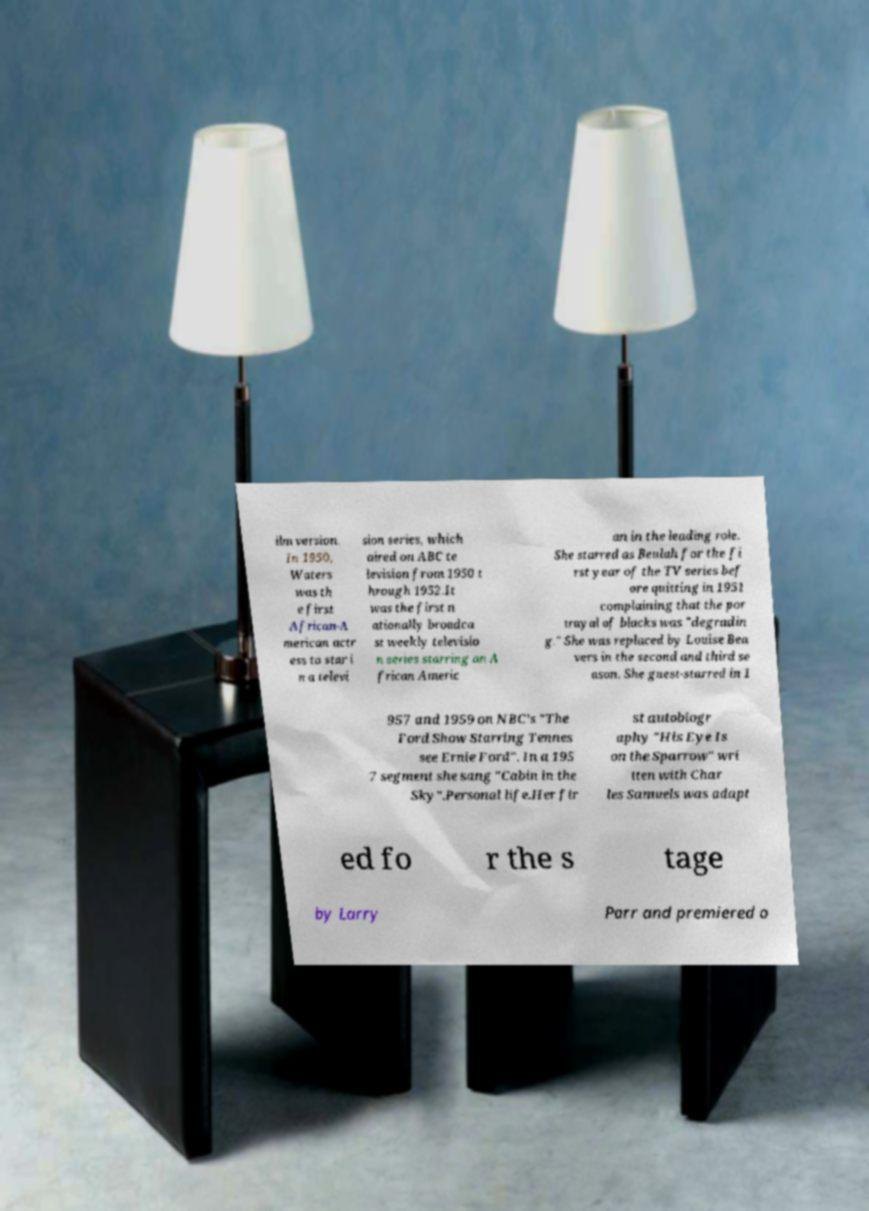I need the written content from this picture converted into text. Can you do that? ilm version. In 1950, Waters was th e first African-A merican actr ess to star i n a televi sion series, which aired on ABC te levision from 1950 t hrough 1952.It was the first n ationally broadca st weekly televisio n series starring an A frican Americ an in the leading role. She starred as Beulah for the fi rst year of the TV series bef ore quitting in 1951 complaining that the por trayal of blacks was "degradin g." She was replaced by Louise Bea vers in the second and third se ason. She guest-starred in 1 957 and 1959 on NBC's "The Ford Show Starring Tennes see Ernie Ford". In a 195 7 segment she sang "Cabin in the Sky".Personal life.Her fir st autobiogr aphy "His Eye Is on the Sparrow" wri tten with Char les Samuels was adapt ed fo r the s tage by Larry Parr and premiered o 